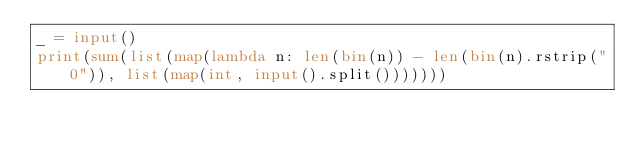<code> <loc_0><loc_0><loc_500><loc_500><_Python_>_ = input()
print(sum(list(map(lambda n: len(bin(n)) - len(bin(n).rstrip("0")), list(map(int, input().split()))))))</code> 